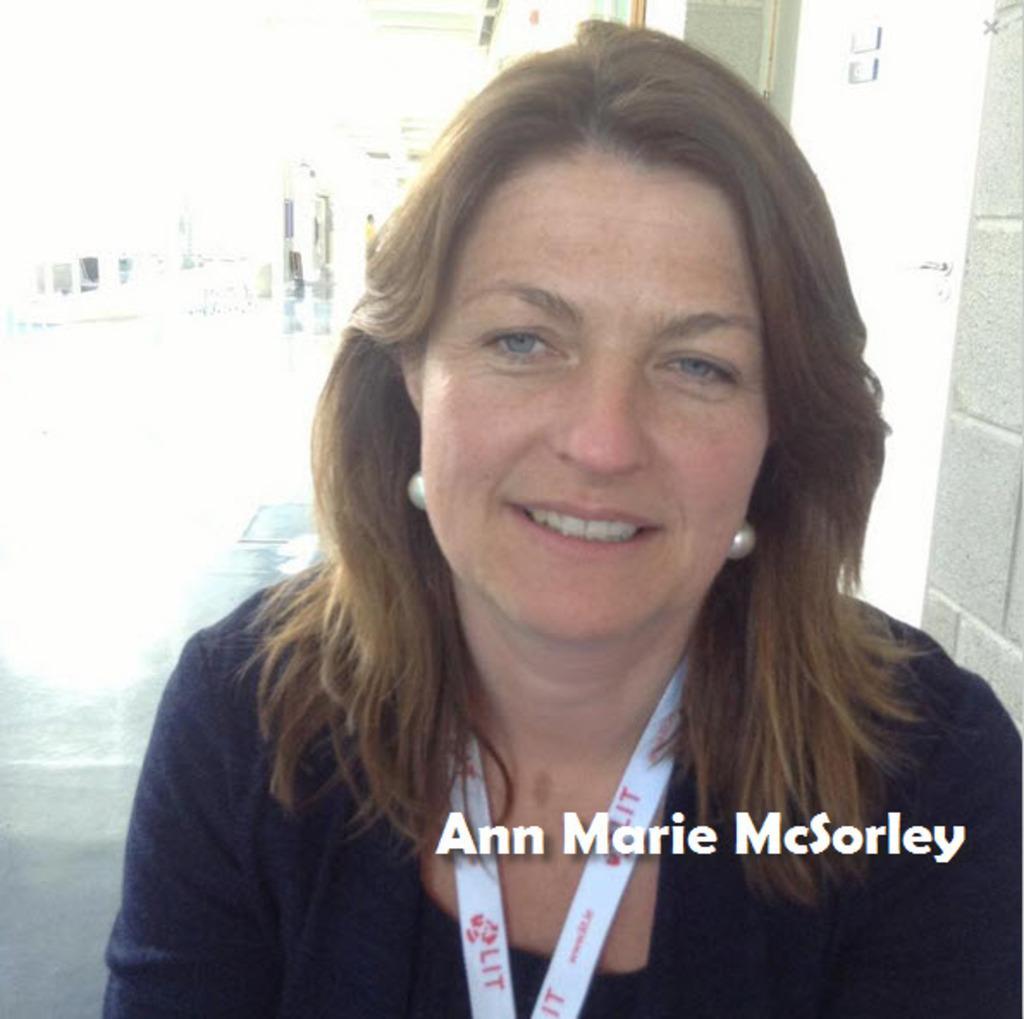Describe this image in one or two sentences. In this image I can see a woman and I can see she is wearing white colour thing around her neck. Here I can see watermark and I can see a wall in background. 